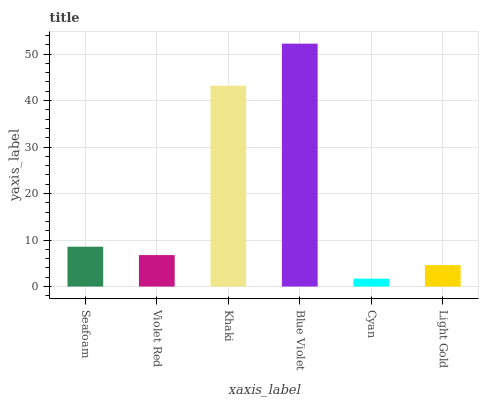Is Cyan the minimum?
Answer yes or no. Yes. Is Blue Violet the maximum?
Answer yes or no. Yes. Is Violet Red the minimum?
Answer yes or no. No. Is Violet Red the maximum?
Answer yes or no. No. Is Seafoam greater than Violet Red?
Answer yes or no. Yes. Is Violet Red less than Seafoam?
Answer yes or no. Yes. Is Violet Red greater than Seafoam?
Answer yes or no. No. Is Seafoam less than Violet Red?
Answer yes or no. No. Is Seafoam the high median?
Answer yes or no. Yes. Is Violet Red the low median?
Answer yes or no. Yes. Is Cyan the high median?
Answer yes or no. No. Is Seafoam the low median?
Answer yes or no. No. 